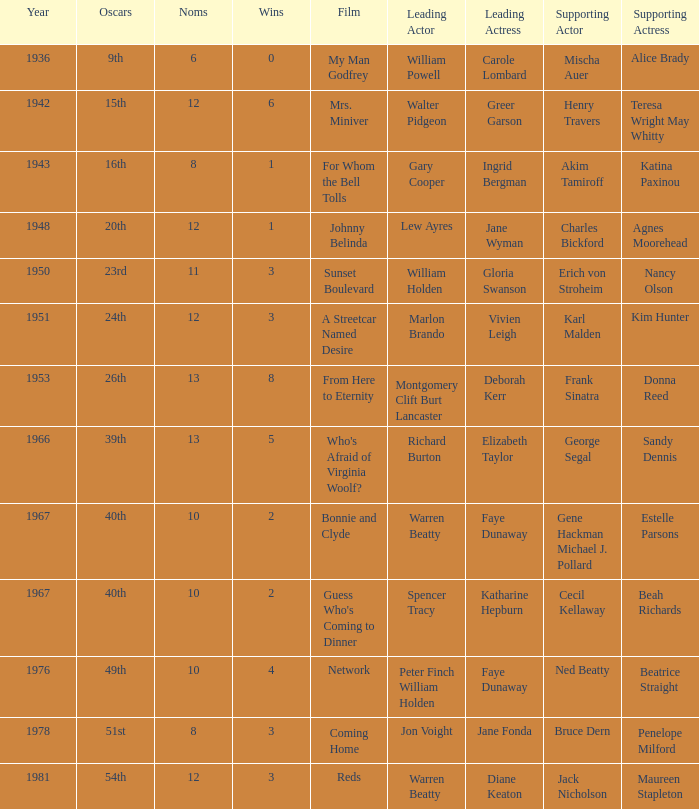In a film where diane keaton was the lead actress, who was the actress in a supporting role? Maureen Stapleton. 